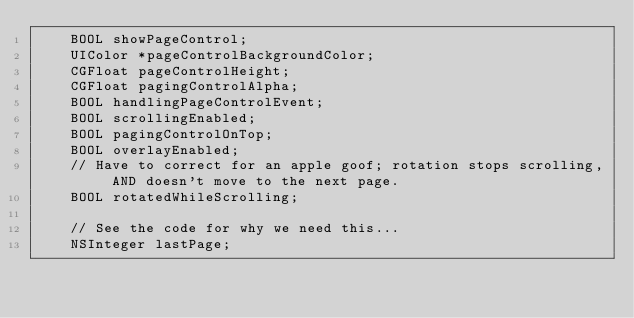Convert code to text. <code><loc_0><loc_0><loc_500><loc_500><_C_>	BOOL showPageControl;
	UIColor *pageControlBackgroundColor;
	CGFloat pageControlHeight;
    CGFloat pagingControlAlpha;
	BOOL handlingPageControlEvent;
    BOOL scrollingEnabled;
    BOOL pagingControlOnTop;
    BOOL overlayEnabled;
    // Have to correct for an apple goof; rotation stops scrolling, AND doesn't move to the next page.
    BOOL rotatedWhileScrolling;

    // See the code for why we need this...
    NSInteger lastPage;</code> 